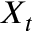<formula> <loc_0><loc_0><loc_500><loc_500>X _ { t }</formula> 